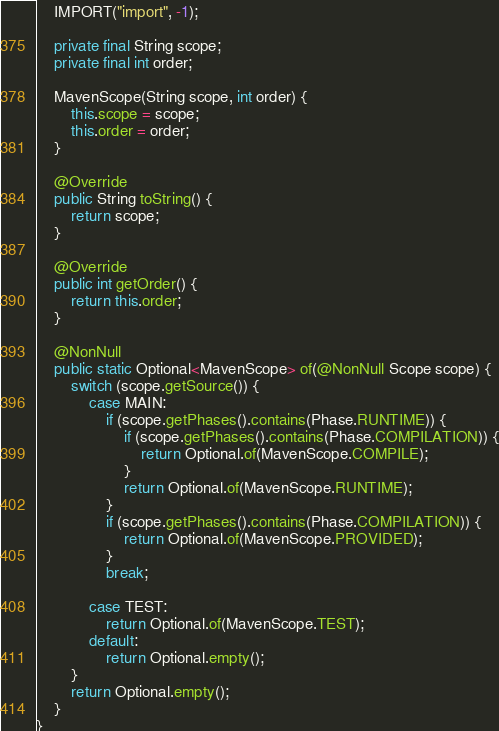Convert code to text. <code><loc_0><loc_0><loc_500><loc_500><_Java_>    IMPORT("import", -1);

    private final String scope;
    private final int order;

    MavenScope(String scope, int order) {
        this.scope = scope;
        this.order = order;
    }

    @Override
    public String toString() {
        return scope;
    }

    @Override
    public int getOrder() {
        return this.order;
    }

    @NonNull
    public static Optional<MavenScope> of(@NonNull Scope scope) {
        switch (scope.getSource()) {
            case MAIN:
                if (scope.getPhases().contains(Phase.RUNTIME)) {
                    if (scope.getPhases().contains(Phase.COMPILATION)) {
                        return Optional.of(MavenScope.COMPILE);
                    }
                    return Optional.of(MavenScope.RUNTIME);
                }
                if (scope.getPhases().contains(Phase.COMPILATION)) {
                    return Optional.of(MavenScope.PROVIDED);
                }
                break;

            case TEST:
                return Optional.of(MavenScope.TEST);
            default:
                return Optional.empty();
        }
        return Optional.empty();
    }
}
</code> 